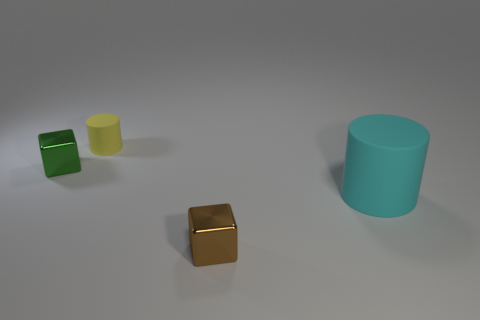Add 4 tiny green rubber cylinders. How many objects exist? 8 Add 4 small green cubes. How many small green cubes exist? 5 Subtract 0 gray spheres. How many objects are left? 4 Subtract all tiny brown cubes. Subtract all brown metal cubes. How many objects are left? 2 Add 3 cyan objects. How many cyan objects are left? 4 